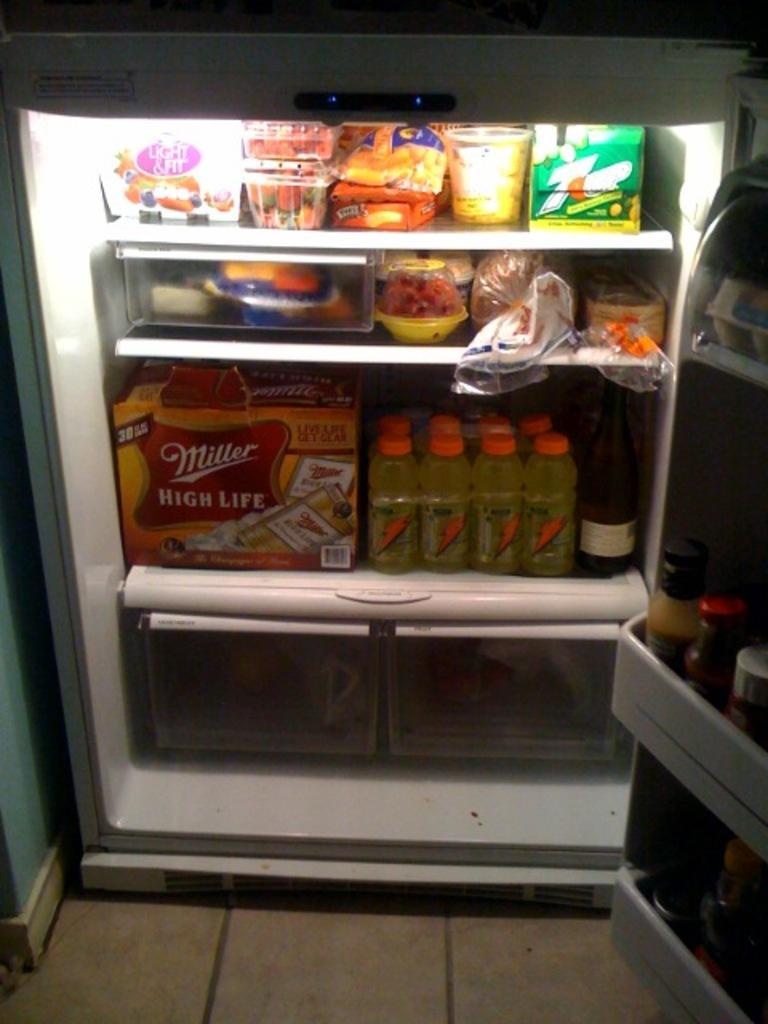In one or two sentences, can you explain what this image depicts? In the center of the image there is a refrigerator and we can see bottles, boxes, tins, bowls, jars, eggs and some food places in the refrigerator. 